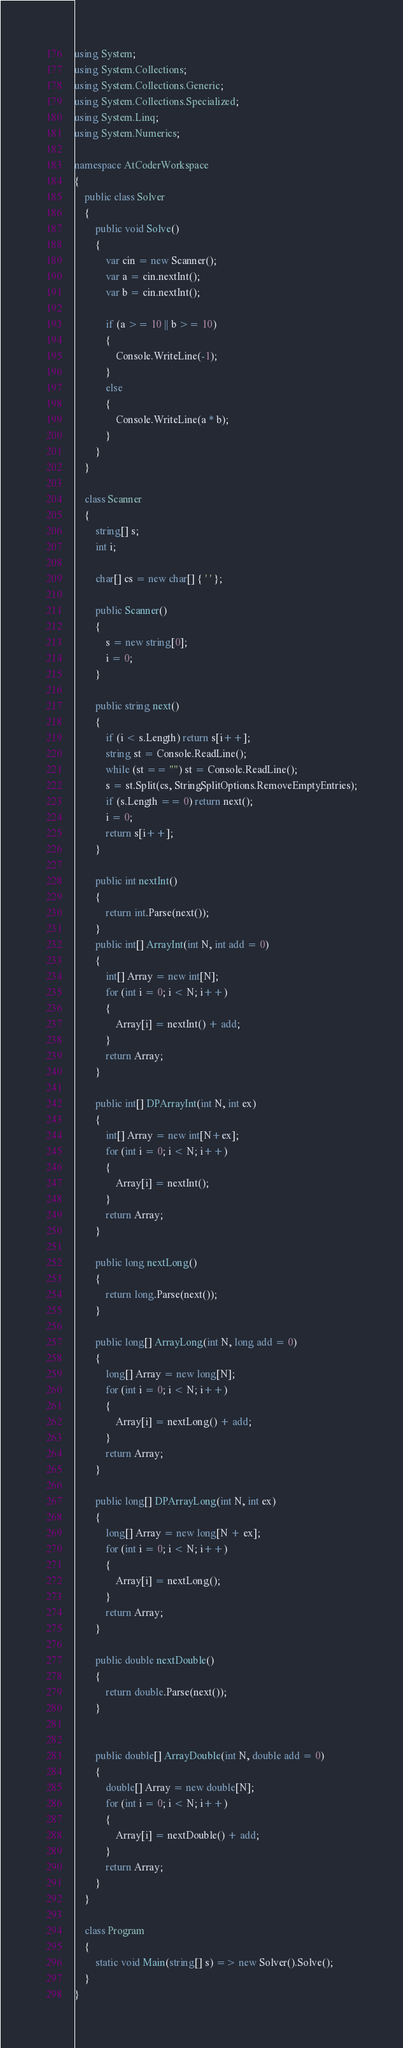<code> <loc_0><loc_0><loc_500><loc_500><_C#_>using System;
using System.Collections;
using System.Collections.Generic;
using System.Collections.Specialized;
using System.Linq;
using System.Numerics;

namespace AtCoderWorkspace
{
    public class Solver
    {
        public void Solve()
        {
            var cin = new Scanner();
            var a = cin.nextInt();
            var b = cin.nextInt();

            if (a >= 10 || b >= 10)
            {
                Console.WriteLine(-1);
            }
            else
            {
                Console.WriteLine(a * b);
            }            
        }
    }

    class Scanner
    {
        string[] s;
        int i;

        char[] cs = new char[] { ' ' };

        public Scanner()
        {
            s = new string[0];
            i = 0;
        }

        public string next()
        {
            if (i < s.Length) return s[i++];
            string st = Console.ReadLine();
            while (st == "") st = Console.ReadLine();
            s = st.Split(cs, StringSplitOptions.RemoveEmptyEntries);
            if (s.Length == 0) return next();
            i = 0;
            return s[i++];
        }

        public int nextInt()
        {
            return int.Parse(next());
        }
        public int[] ArrayInt(int N, int add = 0)
        {
            int[] Array = new int[N];
            for (int i = 0; i < N; i++)
            {
                Array[i] = nextInt() + add;
            }
            return Array;
        }

        public int[] DPArrayInt(int N, int ex)
        {
            int[] Array = new int[N+ex];
            for (int i = 0; i < N; i++)
            {
                Array[i] = nextInt();
            }
            return Array;
        }

        public long nextLong()
        {
            return long.Parse(next());
        }

        public long[] ArrayLong(int N, long add = 0)
        {
            long[] Array = new long[N];
            for (int i = 0; i < N; i++)
            {
                Array[i] = nextLong() + add;
            }
            return Array;
        }

        public long[] DPArrayLong(int N, int ex)
        {
            long[] Array = new long[N + ex];
            for (int i = 0; i < N; i++)
            {
                Array[i] = nextLong();
            }
            return Array;
        }

        public double nextDouble()
        {
            return double.Parse(next());
        }


        public double[] ArrayDouble(int N, double add = 0)
        {
            double[] Array = new double[N];
            for (int i = 0; i < N; i++)
            {
                Array[i] = nextDouble() + add;
            }
            return Array;
        }
    }   

    class Program
    {
        static void Main(string[] s) => new Solver().Solve();
    }
}
</code> 